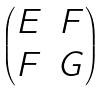Convert formula to latex. <formula><loc_0><loc_0><loc_500><loc_500>\begin{pmatrix} E & F \\ F & G \\ \end{pmatrix}</formula> 